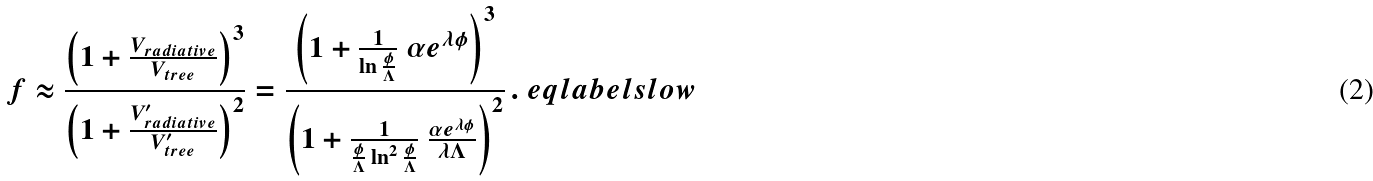<formula> <loc_0><loc_0><loc_500><loc_500>f \approx \frac { \left ( 1 + \frac { V _ { r a d i a t i v e } } { V _ { t r e e } } \right ) ^ { 3 } } { \left ( 1 + \frac { V _ { r a d i a t i v e } ^ { \prime } } { V _ { t r e e } ^ { \prime } } \right ) ^ { 2 } } = \frac { \left ( 1 + \frac { 1 } { \ln \frac { \phi } { \Lambda } } \ { \alpha e ^ { \lambda \phi } } \right ) ^ { 3 } } { \left ( 1 + \frac { 1 } { \frac { \phi } { \Lambda } \ln ^ { 2 } \frac { \phi } { \Lambda } } \ \frac { \alpha e ^ { \lambda \phi } } { \lambda \Lambda } \right ) ^ { 2 } } \, . \ e q l a b e l { s l o w }</formula> 